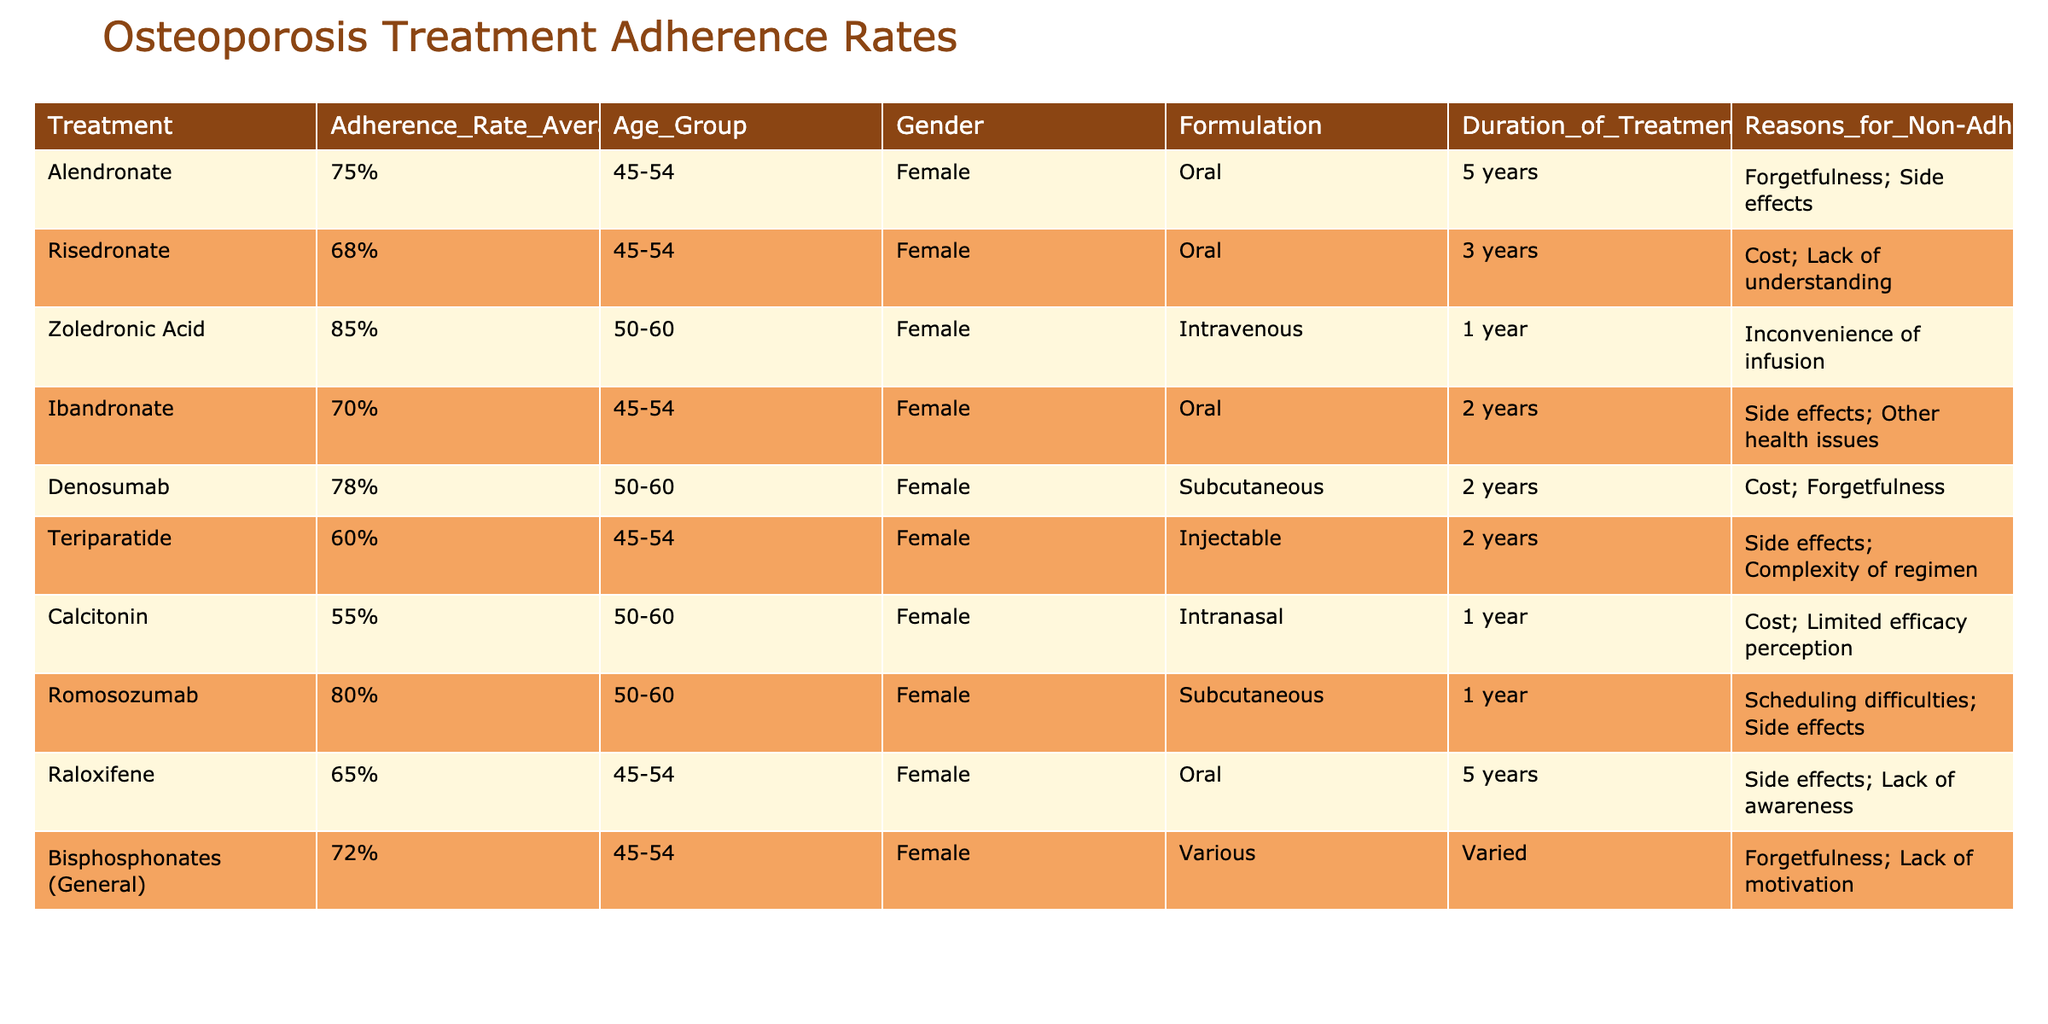What's the adherence rate for Alendronate among middle-aged women? The table shows the adherence rate for Alendronate listed as 75%.
Answer: 75% Which osteoporosis treatment has the highest adherence rate among the listed medications for the age group 50-60? According to the table, Zoledronic Acid has the highest adherence rate at 85%.
Answer: 85% What are the reasons for non-adherence to Denosumab? The table lists the reasons for non-adherence to Denosumab as cost and forgetfulness.
Answer: Cost; Forgetfulness Is the adherence rate for Ibandronate higher than that for Risedronate? The table shows Ibandronate at 70% and Risedronate at 68%. Since 70% is greater than 68%, the answer is yes.
Answer: Yes What is the average adherence rate for osteoporosis treatments for middle-aged women aged 45-54? The adherence rates for this age group are 75%, 68%, 70%, 60%, and 65%. Calculating the average: (75 + 68 + 70 + 60 + 65) = 338 and dividing by 5 gives 67.6%.
Answer: 67.6% Are there any treatments with an adherence rate below 60%? The table shows that the treatments with adherence rates below 60% are Teriparatide at 60% and Calcitonin at 55%. Since there is one treatment at 55%, the answer is no.
Answer: No How many treatments have an adherence rate above 70%? The treatments with adherence rates above 70% are Alendronate (75%), Zoledronic Acid (85%), Denosumab (78%), and Romosozumab (80%). Therefore, there are four treatments above 70%.
Answer: 4 What is the difference in adherence rates between Zoledronic Acid and Teriparatide? The adherence rate for Zoledronic Acid is 85% and for Teriparatide, it is 60%. To find the difference, we subtract: 85% - 60% = 25%.
Answer: 25% List all the formulations that have an adherence rate lower than 70% and their adherence rates. The formulations with adherence rates lower than 70% are: Risedronate (68%), Ibandronate (70%), Teriparatide (60%), and Calcitonin (55%). Therefore, the list includes Risedronate: 68%, Ibandronate: 70%, Teriparatide: 60%, and Calcitonin: 55%.
Answer: Risedronate: 68%; Ibandronate: 70%; Teriparatide: 60%; Calcitonin: 55% 